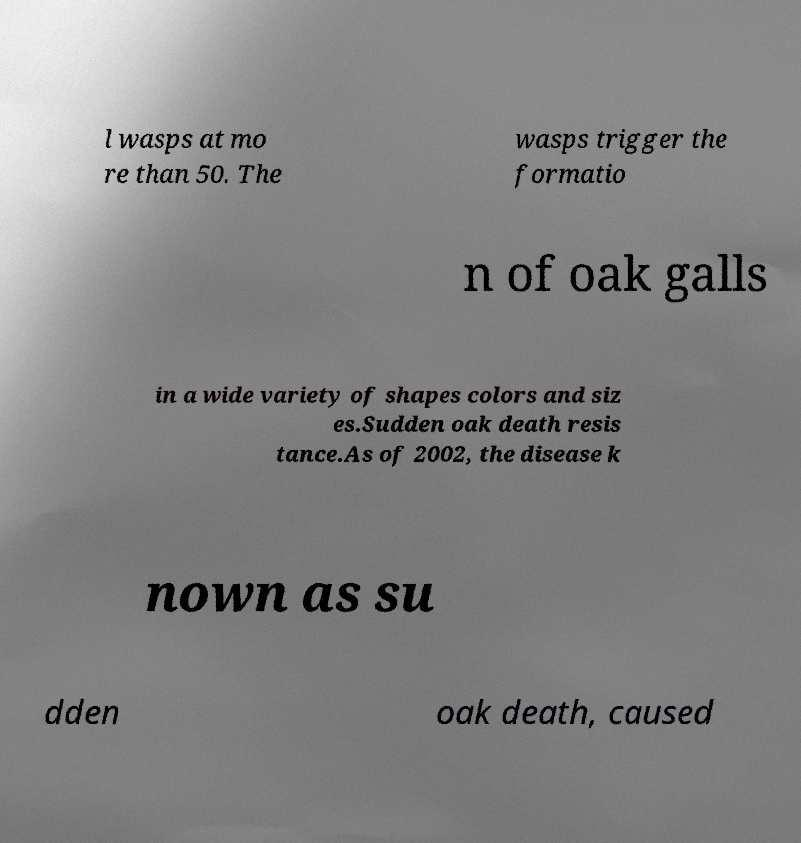Can you accurately transcribe the text from the provided image for me? l wasps at mo re than 50. The wasps trigger the formatio n of oak galls in a wide variety of shapes colors and siz es.Sudden oak death resis tance.As of 2002, the disease k nown as su dden oak death, caused 